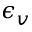<formula> <loc_0><loc_0><loc_500><loc_500>\epsilon _ { v }</formula> 